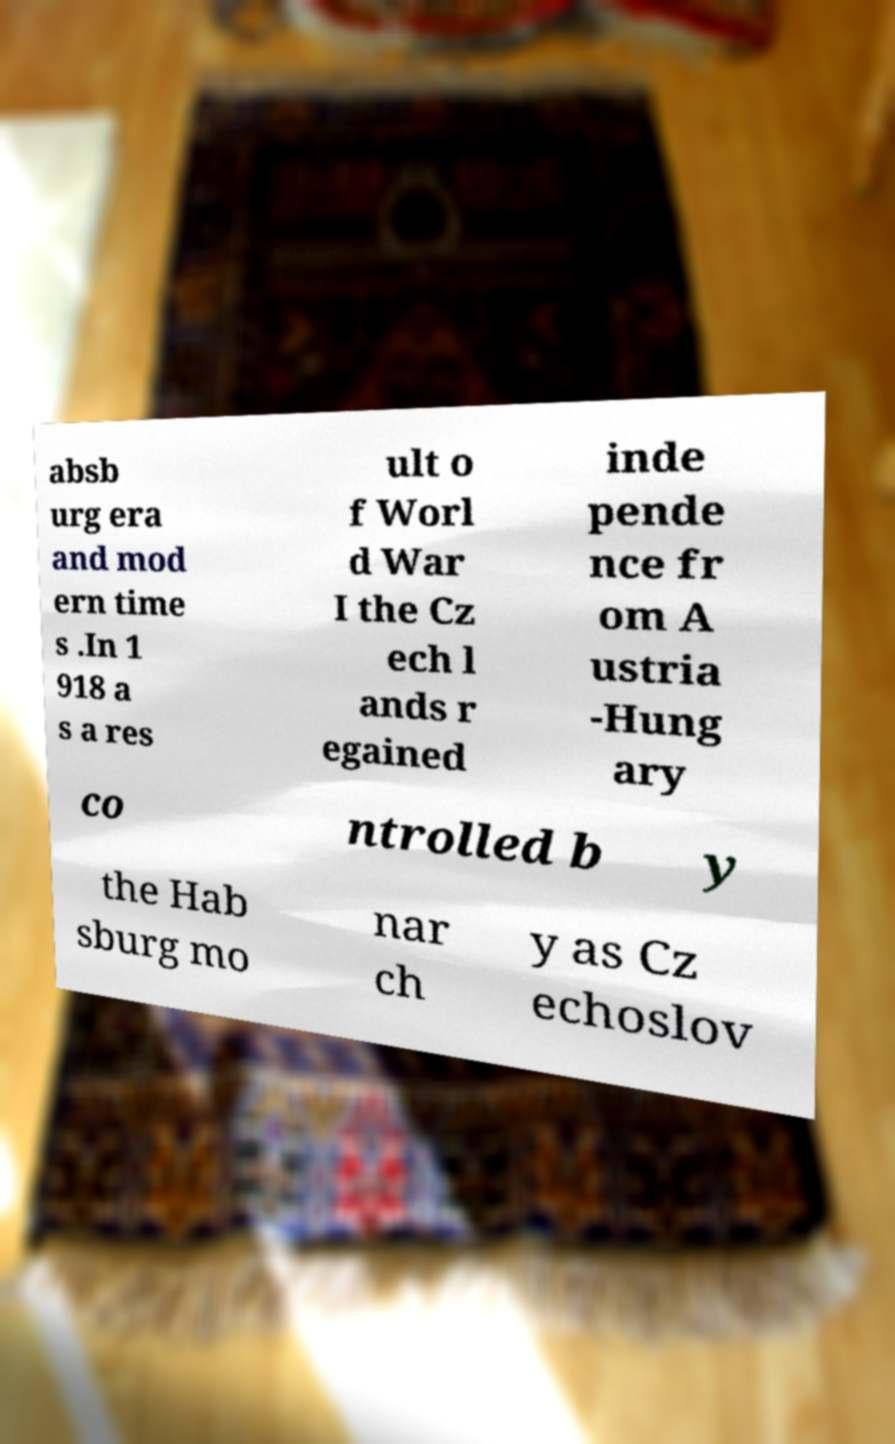There's text embedded in this image that I need extracted. Can you transcribe it verbatim? absb urg era and mod ern time s .In 1 918 a s a res ult o f Worl d War I the Cz ech l ands r egained inde pende nce fr om A ustria -Hung ary co ntrolled b y the Hab sburg mo nar ch y as Cz echoslov 